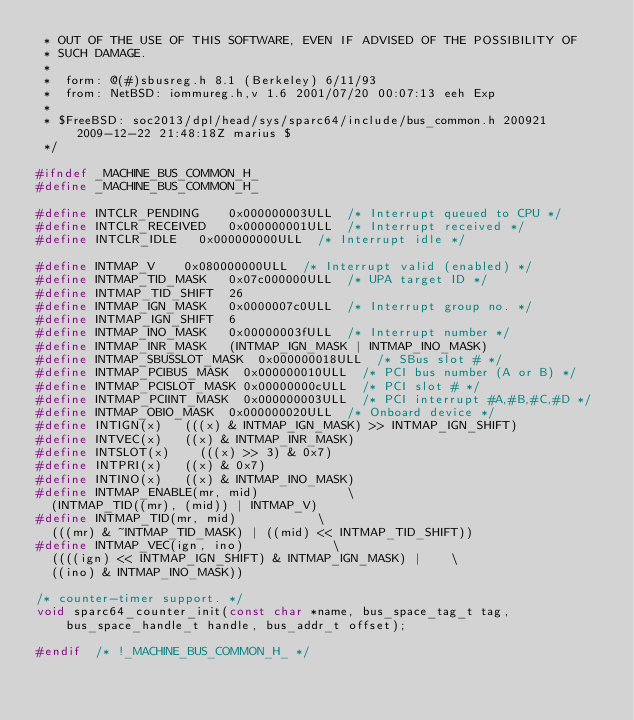Convert code to text. <code><loc_0><loc_0><loc_500><loc_500><_C_> * OUT OF THE USE OF THIS SOFTWARE, EVEN IF ADVISED OF THE POSSIBILITY OF
 * SUCH DAMAGE.
 *
 *	form: @(#)sbusreg.h	8.1 (Berkeley) 6/11/93
 *	from: NetBSD: iommureg.h,v 1.6 2001/07/20 00:07:13 eeh Exp
 *
 * $FreeBSD: soc2013/dpl/head/sys/sparc64/include/bus_common.h 200921 2009-12-22 21:48:18Z marius $
 */

#ifndef _MACHINE_BUS_COMMON_H_
#define	_MACHINE_BUS_COMMON_H_

#define	INTCLR_PENDING		0x000000003ULL	/* Interrupt queued to CPU */
#define	INTCLR_RECEIVED		0x000000001ULL	/* Interrupt received */
#define	INTCLR_IDLE		0x000000000ULL	/* Interrupt idle */

#define	INTMAP_V		0x080000000ULL	/* Interrupt valid (enabled) */
#define	INTMAP_TID_MASK		0x07c000000ULL	/* UPA target ID */
#define	INTMAP_TID_SHIFT	26
#define	INTMAP_IGN_MASK		0x0000007c0ULL	/* Interrupt group no. */
#define	INTMAP_IGN_SHIFT	6
#define	INTMAP_INO_MASK		0x00000003fULL	/* Interrupt number */
#define	INTMAP_INR_MASK		(INTMAP_IGN_MASK | INTMAP_INO_MASK)
#define	INTMAP_SBUSSLOT_MASK	0x000000018ULL	/* SBus slot # */
#define	INTMAP_PCIBUS_MASK	0x000000010ULL	/* PCI bus number (A or B) */
#define	INTMAP_PCISLOT_MASK	0x00000000cULL	/* PCI slot # */
#define	INTMAP_PCIINT_MASK	0x000000003ULL	/* PCI interrupt #A,#B,#C,#D */
#define	INTMAP_OBIO_MASK	0x000000020ULL	/* Onboard device */
#define	INTIGN(x)		(((x) & INTMAP_IGN_MASK) >> INTMAP_IGN_SHIFT)
#define	INTVEC(x)		((x) & INTMAP_INR_MASK)
#define	INTSLOT(x)		(((x) >> 3) & 0x7)
#define	INTPRI(x)		((x) & 0x7)
#define	INTINO(x)		((x) & INTMAP_INO_MASK)
#define	INTMAP_ENABLE(mr, mid)						\
	(INTMAP_TID((mr), (mid)) | INTMAP_V)
#define	INTMAP_TID(mr, mid)						\
	(((mr) & ~INTMAP_TID_MASK) | ((mid) << INTMAP_TID_SHIFT))
#define	INTMAP_VEC(ign, ino)						\
	((((ign) << INTMAP_IGN_SHIFT) & INTMAP_IGN_MASK) |		\
	((ino) & INTMAP_INO_MASK))

/* counter-timer support. */
void sparc64_counter_init(const char *name, bus_space_tag_t tag,
    bus_space_handle_t handle, bus_addr_t offset);

#endif	/* !_MACHINE_BUS_COMMON_H_ */
</code> 